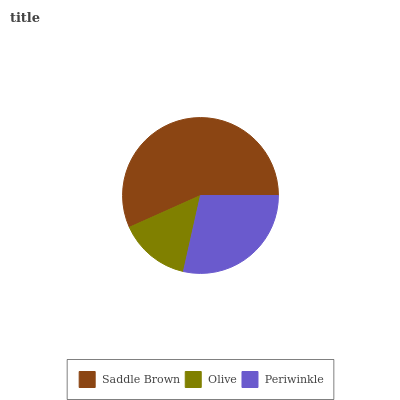Is Olive the minimum?
Answer yes or no. Yes. Is Saddle Brown the maximum?
Answer yes or no. Yes. Is Periwinkle the minimum?
Answer yes or no. No. Is Periwinkle the maximum?
Answer yes or no. No. Is Periwinkle greater than Olive?
Answer yes or no. Yes. Is Olive less than Periwinkle?
Answer yes or no. Yes. Is Olive greater than Periwinkle?
Answer yes or no. No. Is Periwinkle less than Olive?
Answer yes or no. No. Is Periwinkle the high median?
Answer yes or no. Yes. Is Periwinkle the low median?
Answer yes or no. Yes. Is Olive the high median?
Answer yes or no. No. Is Saddle Brown the low median?
Answer yes or no. No. 